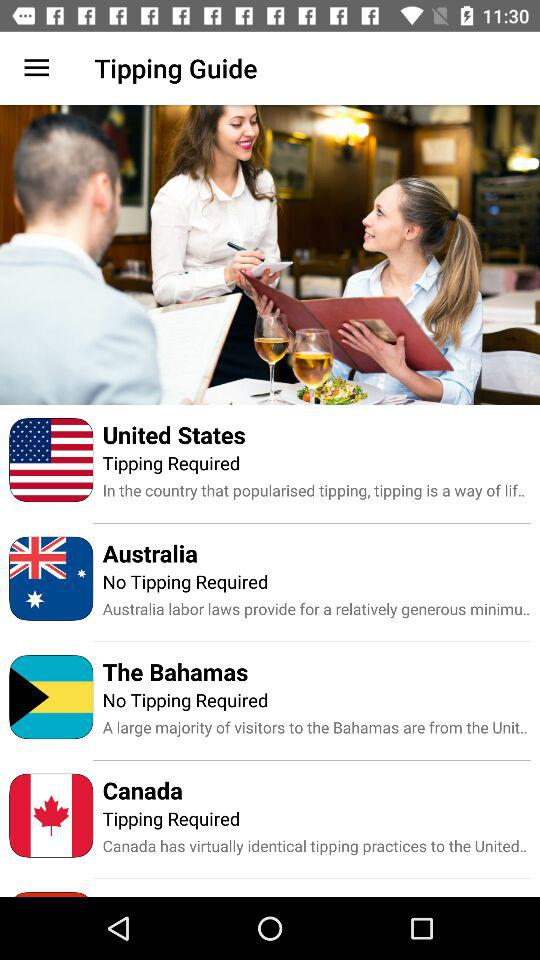Is tipping required in Australia? There is no tipping required in Australia. 